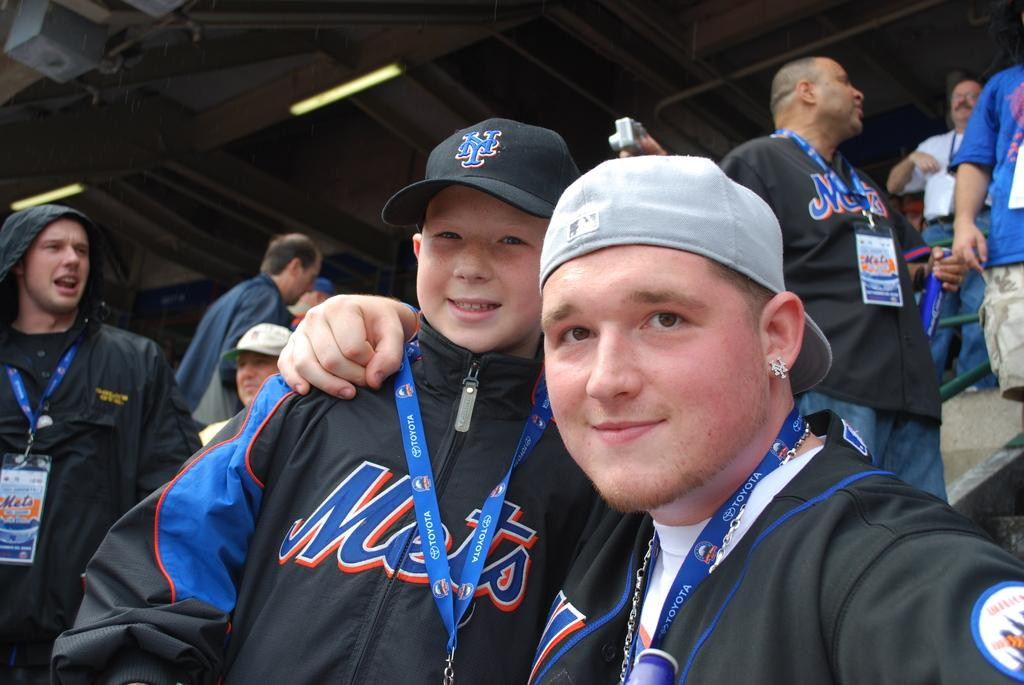<image>
Create a compact narrative representing the image presented. A man embraces a boy at a Mets sporting event. 